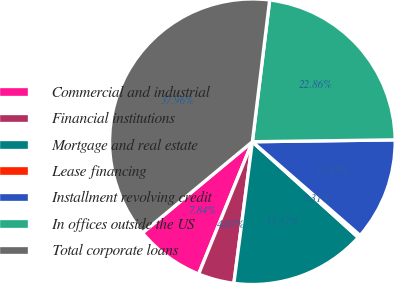<chart> <loc_0><loc_0><loc_500><loc_500><pie_chart><fcel>Commercial and industrial<fcel>Financial institutions<fcel>Mortgage and real estate<fcel>Lease financing<fcel>Installment revolving credit<fcel>In offices outside the US<fcel>Total corporate loans<nl><fcel>7.84%<fcel>4.07%<fcel>15.37%<fcel>0.31%<fcel>11.6%<fcel>22.86%<fcel>37.96%<nl></chart> 